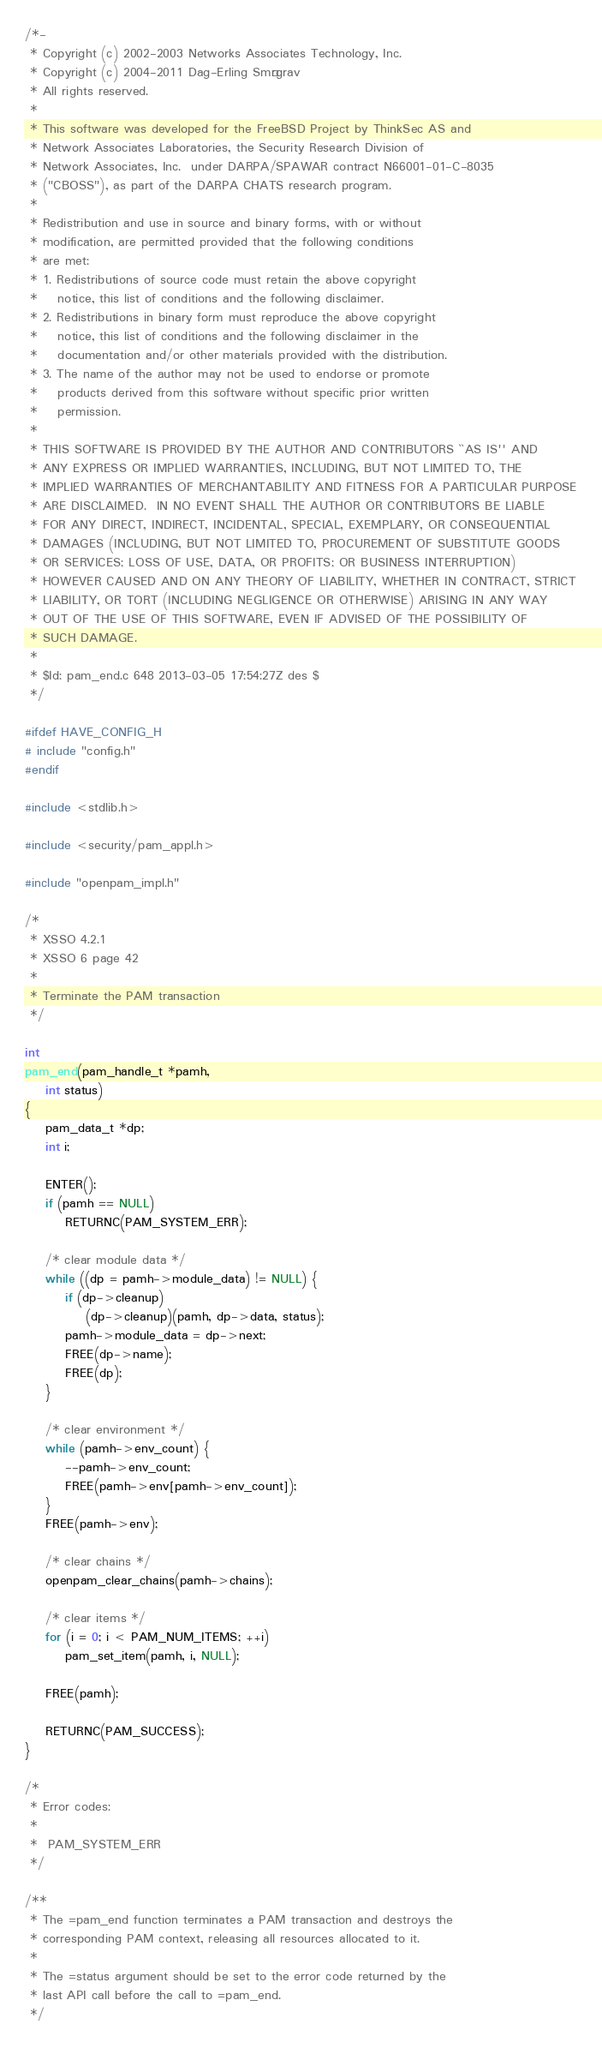<code> <loc_0><loc_0><loc_500><loc_500><_C_>/*-
 * Copyright (c) 2002-2003 Networks Associates Technology, Inc.
 * Copyright (c) 2004-2011 Dag-Erling Smørgrav
 * All rights reserved.
 *
 * This software was developed for the FreeBSD Project by ThinkSec AS and
 * Network Associates Laboratories, the Security Research Division of
 * Network Associates, Inc.  under DARPA/SPAWAR contract N66001-01-C-8035
 * ("CBOSS"), as part of the DARPA CHATS research program.
 *
 * Redistribution and use in source and binary forms, with or without
 * modification, are permitted provided that the following conditions
 * are met:
 * 1. Redistributions of source code must retain the above copyright
 *    notice, this list of conditions and the following disclaimer.
 * 2. Redistributions in binary form must reproduce the above copyright
 *    notice, this list of conditions and the following disclaimer in the
 *    documentation and/or other materials provided with the distribution.
 * 3. The name of the author may not be used to endorse or promote
 *    products derived from this software without specific prior written
 *    permission.
 *
 * THIS SOFTWARE IS PROVIDED BY THE AUTHOR AND CONTRIBUTORS ``AS IS'' AND
 * ANY EXPRESS OR IMPLIED WARRANTIES, INCLUDING, BUT NOT LIMITED TO, THE
 * IMPLIED WARRANTIES OF MERCHANTABILITY AND FITNESS FOR A PARTICULAR PURPOSE
 * ARE DISCLAIMED.  IN NO EVENT SHALL THE AUTHOR OR CONTRIBUTORS BE LIABLE
 * FOR ANY DIRECT, INDIRECT, INCIDENTAL, SPECIAL, EXEMPLARY, OR CONSEQUENTIAL
 * DAMAGES (INCLUDING, BUT NOT LIMITED TO, PROCUREMENT OF SUBSTITUTE GOODS
 * OR SERVICES; LOSS OF USE, DATA, OR PROFITS; OR BUSINESS INTERRUPTION)
 * HOWEVER CAUSED AND ON ANY THEORY OF LIABILITY, WHETHER IN CONTRACT, STRICT
 * LIABILITY, OR TORT (INCLUDING NEGLIGENCE OR OTHERWISE) ARISING IN ANY WAY
 * OUT OF THE USE OF THIS SOFTWARE, EVEN IF ADVISED OF THE POSSIBILITY OF
 * SUCH DAMAGE.
 *
 * $Id: pam_end.c 648 2013-03-05 17:54:27Z des $
 */

#ifdef HAVE_CONFIG_H
# include "config.h"
#endif

#include <stdlib.h>

#include <security/pam_appl.h>

#include "openpam_impl.h"

/*
 * XSSO 4.2.1
 * XSSO 6 page 42
 *
 * Terminate the PAM transaction
 */

int
pam_end(pam_handle_t *pamh,
	int status)
{
	pam_data_t *dp;
	int i;

	ENTER();
	if (pamh == NULL)
		RETURNC(PAM_SYSTEM_ERR);

	/* clear module data */
	while ((dp = pamh->module_data) != NULL) {
		if (dp->cleanup)
			(dp->cleanup)(pamh, dp->data, status);
		pamh->module_data = dp->next;
		FREE(dp->name);
		FREE(dp);
	}

	/* clear environment */
	while (pamh->env_count) {
		--pamh->env_count;
		FREE(pamh->env[pamh->env_count]);
	}
	FREE(pamh->env);

	/* clear chains */
	openpam_clear_chains(pamh->chains);

	/* clear items */
	for (i = 0; i < PAM_NUM_ITEMS; ++i)
		pam_set_item(pamh, i, NULL);

	FREE(pamh);

	RETURNC(PAM_SUCCESS);
}

/*
 * Error codes:
 *
 *	PAM_SYSTEM_ERR
 */

/**
 * The =pam_end function terminates a PAM transaction and destroys the
 * corresponding PAM context, releasing all resources allocated to it.
 *
 * The =status argument should be set to the error code returned by the
 * last API call before the call to =pam_end.
 */
</code> 